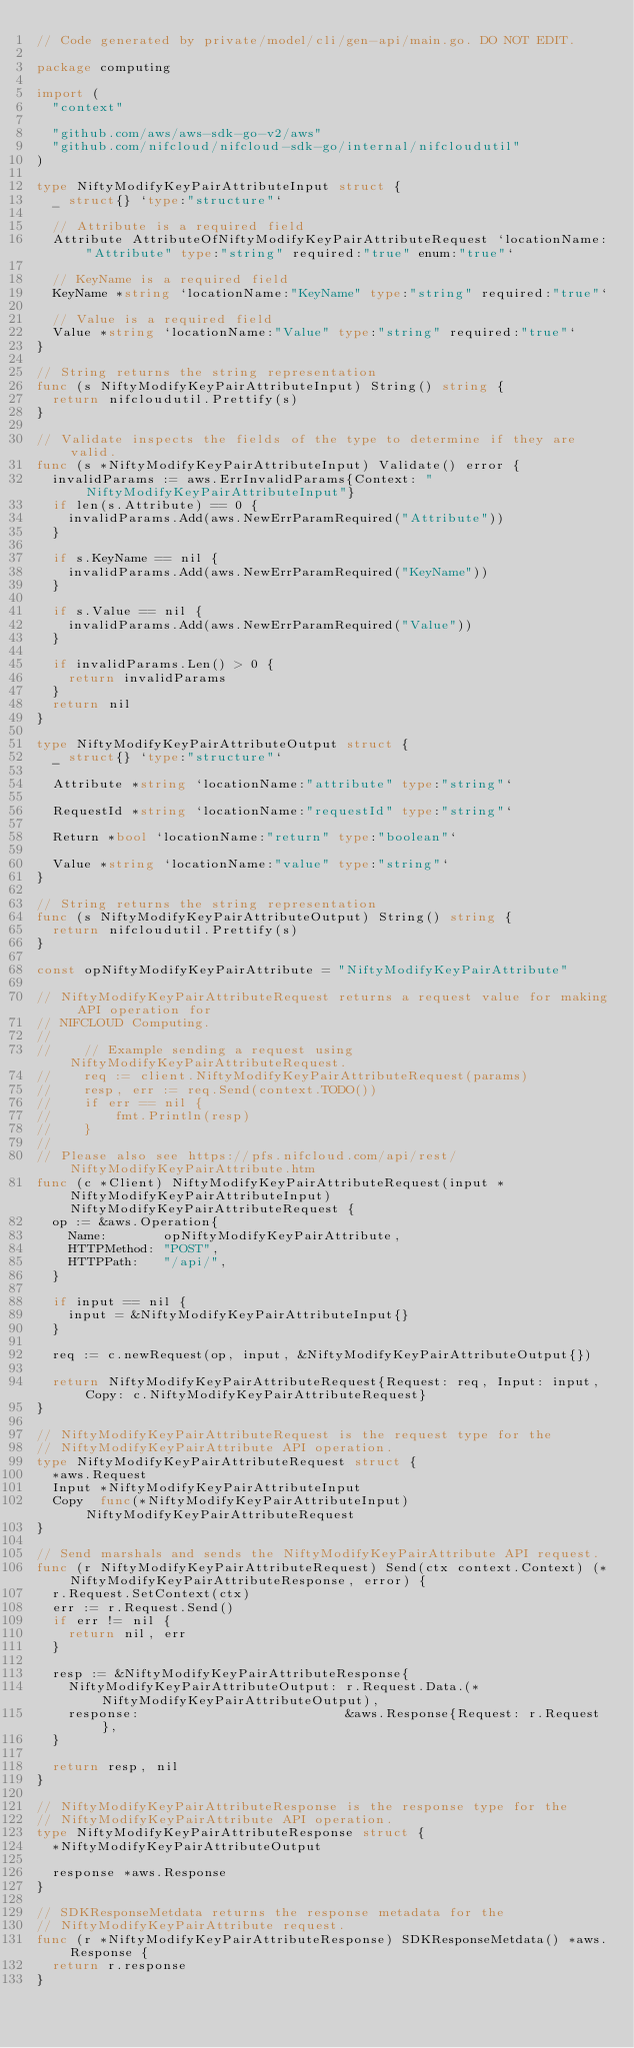Convert code to text. <code><loc_0><loc_0><loc_500><loc_500><_Go_>// Code generated by private/model/cli/gen-api/main.go. DO NOT EDIT.

package computing

import (
	"context"

	"github.com/aws/aws-sdk-go-v2/aws"
	"github.com/nifcloud/nifcloud-sdk-go/internal/nifcloudutil"
)

type NiftyModifyKeyPairAttributeInput struct {
	_ struct{} `type:"structure"`

	// Attribute is a required field
	Attribute AttributeOfNiftyModifyKeyPairAttributeRequest `locationName:"Attribute" type:"string" required:"true" enum:"true"`

	// KeyName is a required field
	KeyName *string `locationName:"KeyName" type:"string" required:"true"`

	// Value is a required field
	Value *string `locationName:"Value" type:"string" required:"true"`
}

// String returns the string representation
func (s NiftyModifyKeyPairAttributeInput) String() string {
	return nifcloudutil.Prettify(s)
}

// Validate inspects the fields of the type to determine if they are valid.
func (s *NiftyModifyKeyPairAttributeInput) Validate() error {
	invalidParams := aws.ErrInvalidParams{Context: "NiftyModifyKeyPairAttributeInput"}
	if len(s.Attribute) == 0 {
		invalidParams.Add(aws.NewErrParamRequired("Attribute"))
	}

	if s.KeyName == nil {
		invalidParams.Add(aws.NewErrParamRequired("KeyName"))
	}

	if s.Value == nil {
		invalidParams.Add(aws.NewErrParamRequired("Value"))
	}

	if invalidParams.Len() > 0 {
		return invalidParams
	}
	return nil
}

type NiftyModifyKeyPairAttributeOutput struct {
	_ struct{} `type:"structure"`

	Attribute *string `locationName:"attribute" type:"string"`

	RequestId *string `locationName:"requestId" type:"string"`

	Return *bool `locationName:"return" type:"boolean"`

	Value *string `locationName:"value" type:"string"`
}

// String returns the string representation
func (s NiftyModifyKeyPairAttributeOutput) String() string {
	return nifcloudutil.Prettify(s)
}

const opNiftyModifyKeyPairAttribute = "NiftyModifyKeyPairAttribute"

// NiftyModifyKeyPairAttributeRequest returns a request value for making API operation for
// NIFCLOUD Computing.
//
//    // Example sending a request using NiftyModifyKeyPairAttributeRequest.
//    req := client.NiftyModifyKeyPairAttributeRequest(params)
//    resp, err := req.Send(context.TODO())
//    if err == nil {
//        fmt.Println(resp)
//    }
//
// Please also see https://pfs.nifcloud.com/api/rest/NiftyModifyKeyPairAttribute.htm
func (c *Client) NiftyModifyKeyPairAttributeRequest(input *NiftyModifyKeyPairAttributeInput) NiftyModifyKeyPairAttributeRequest {
	op := &aws.Operation{
		Name:       opNiftyModifyKeyPairAttribute,
		HTTPMethod: "POST",
		HTTPPath:   "/api/",
	}

	if input == nil {
		input = &NiftyModifyKeyPairAttributeInput{}
	}

	req := c.newRequest(op, input, &NiftyModifyKeyPairAttributeOutput{})

	return NiftyModifyKeyPairAttributeRequest{Request: req, Input: input, Copy: c.NiftyModifyKeyPairAttributeRequest}
}

// NiftyModifyKeyPairAttributeRequest is the request type for the
// NiftyModifyKeyPairAttribute API operation.
type NiftyModifyKeyPairAttributeRequest struct {
	*aws.Request
	Input *NiftyModifyKeyPairAttributeInput
	Copy  func(*NiftyModifyKeyPairAttributeInput) NiftyModifyKeyPairAttributeRequest
}

// Send marshals and sends the NiftyModifyKeyPairAttribute API request.
func (r NiftyModifyKeyPairAttributeRequest) Send(ctx context.Context) (*NiftyModifyKeyPairAttributeResponse, error) {
	r.Request.SetContext(ctx)
	err := r.Request.Send()
	if err != nil {
		return nil, err
	}

	resp := &NiftyModifyKeyPairAttributeResponse{
		NiftyModifyKeyPairAttributeOutput: r.Request.Data.(*NiftyModifyKeyPairAttributeOutput),
		response:                          &aws.Response{Request: r.Request},
	}

	return resp, nil
}

// NiftyModifyKeyPairAttributeResponse is the response type for the
// NiftyModifyKeyPairAttribute API operation.
type NiftyModifyKeyPairAttributeResponse struct {
	*NiftyModifyKeyPairAttributeOutput

	response *aws.Response
}

// SDKResponseMetdata returns the response metadata for the
// NiftyModifyKeyPairAttribute request.
func (r *NiftyModifyKeyPairAttributeResponse) SDKResponseMetdata() *aws.Response {
	return r.response
}
</code> 